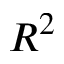Convert formula to latex. <formula><loc_0><loc_0><loc_500><loc_500>R ^ { 2 }</formula> 